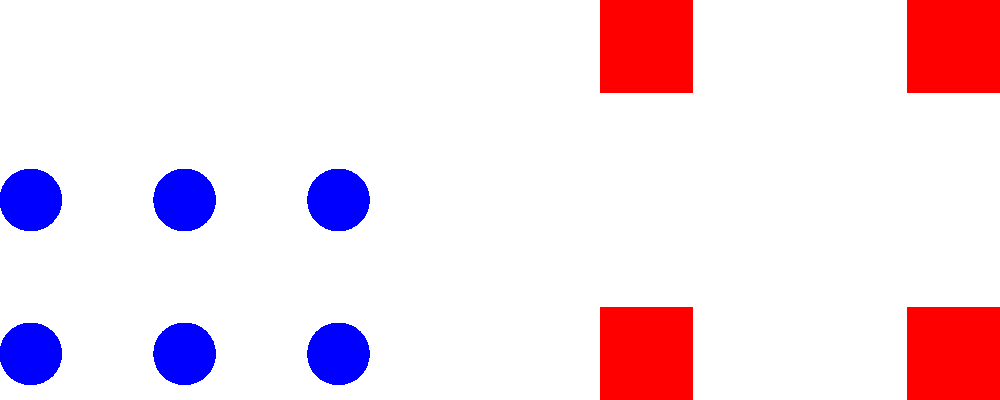Based on the satellite imagery of enemy troop formations shown above, what type of offensive operation is the enemy most likely preparing for, and how would you deploy your ground forces to counter this threat? To answer this question, we need to analyze the enemy troop formations and their implications:

1. Formation analysis:
   a. Infantry (blue circles): Deployed in a rectangular formation, suggesting a strong front line.
   b. Armor (red squares): Positioned behind the infantry, indicating a second echelon or breakthrough force.
   c. Artillery (green triangles): Located at the rear, providing fire support.

2. Offensive operation assessment:
   This formation is characteristic of a combined arms assault, with:
   a. Infantry leading the attack to engage and fix enemy positions.
   b. Armor ready to exploit breakthroughs or reinforce the infantry.
   c. Artillery providing suppressive fire and targeting key enemy positions.

3. Likely enemy strategy:
   The enemy is probably planning a frontal assault with the aim of breaking through our defensive lines using concentrated force.

4. Counter-deployment strategy:
   a. Establish a strong defensive line with infantry in prepared positions to withstand the initial assault.
   b. Position our own armor units on the flanks for potential counterattacks or to blunt enemy armored breakthroughs.
   c. Deploy anti-tank units interspersed with infantry to counter enemy armor.
   d. Set up artillery in protected positions to counter-battery enemy artillery and disrupt their formations.
   e. Maintain a mobile reserve force to reinforce threatened sectors or exploit enemy weaknesses.

5. Key considerations:
   a. Use terrain features to our advantage, channeling enemy forces into kill zones.
   b. Establish overlapping fields of fire to maximize defensive effectiveness.
   c. Prepare fallback positions in case of breakthrough.
   d. Ensure robust communication for coordinated defense and timely reinforcement.
Answer: Deploy in-depth defense with strong infantry front, flanking armor, interspersed anti-tank units, protected artillery, and mobile reserves. 